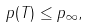<formula> <loc_0><loc_0><loc_500><loc_500>\| p ( T ) \| \leq \| p \| _ { \infty } ,</formula> 